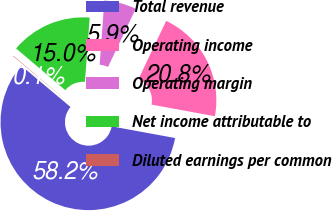Convert chart to OTSL. <chart><loc_0><loc_0><loc_500><loc_500><pie_chart><fcel>Total revenue<fcel>Operating income<fcel>Operating margin<fcel>Net income attributable to<fcel>Diluted earnings per common<nl><fcel>58.22%<fcel>20.83%<fcel>5.89%<fcel>14.98%<fcel>0.08%<nl></chart> 